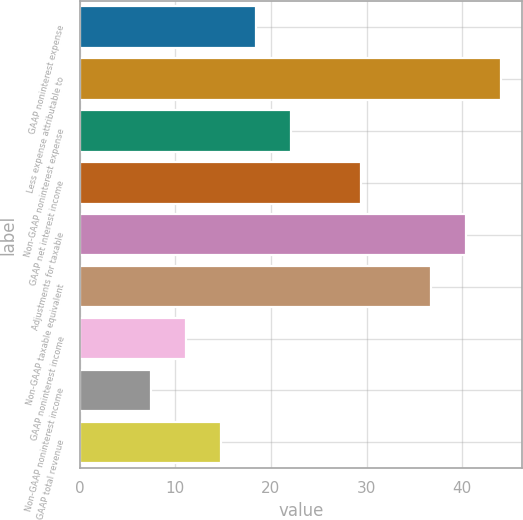<chart> <loc_0><loc_0><loc_500><loc_500><bar_chart><fcel>GAAP noninterest expense<fcel>Less expense attributable to<fcel>Non-GAAP noninterest expense<fcel>GAAP net interest income<fcel>Adjustments for taxable<fcel>Non-GAAP taxable equivalent<fcel>GAAP noninterest income<fcel>Non-GAAP noninterest income<fcel>GAAP total revenue<nl><fcel>18.4<fcel>44.02<fcel>22.06<fcel>29.38<fcel>40.36<fcel>36.7<fcel>11.08<fcel>7.42<fcel>14.74<nl></chart> 